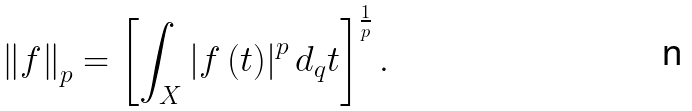Convert formula to latex. <formula><loc_0><loc_0><loc_500><loc_500>\left \| f \right \| _ { p } = \left [ \int _ { X } \left | f \left ( t \right ) \right | ^ { p } d _ { q } t \right ] ^ { \frac { 1 } { p } } .</formula> 